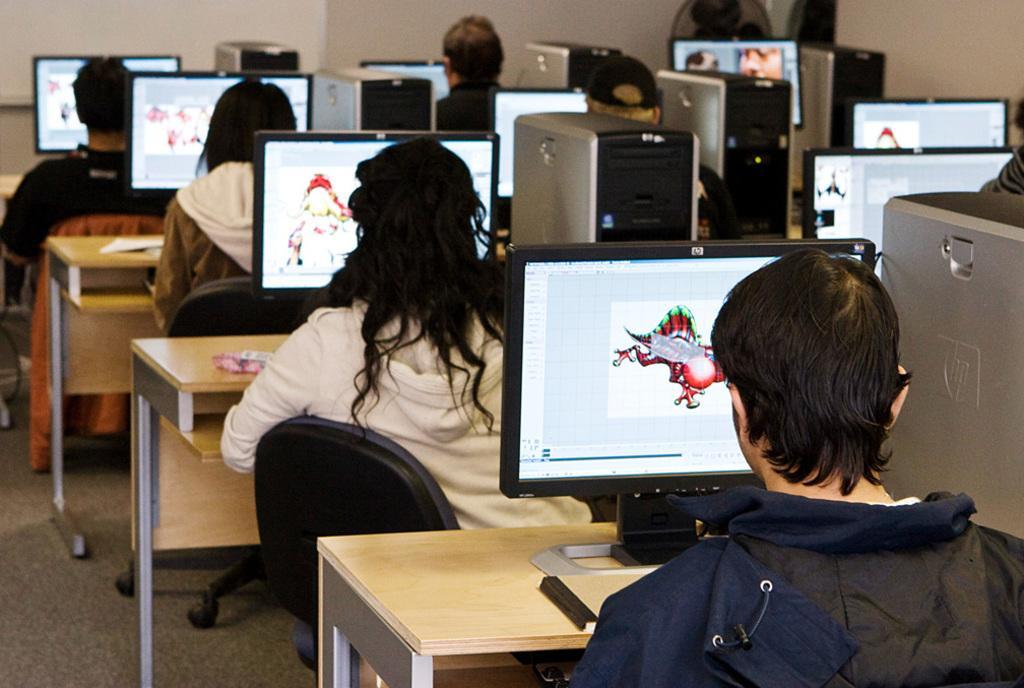Please provide a concise description of this image. In this picture we can see a group of people sitting on chairs and in front of them there is table and on table we have monitors, papers, CPU and in background we can see wall, fan. 